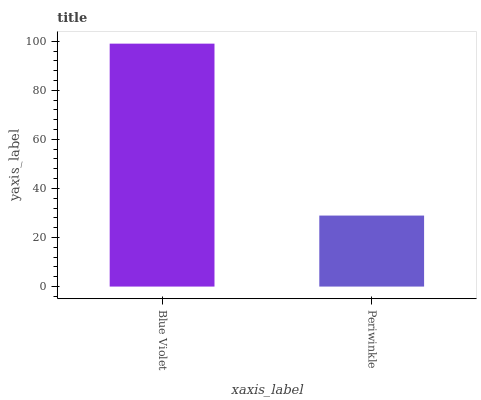Is Periwinkle the minimum?
Answer yes or no. Yes. Is Blue Violet the maximum?
Answer yes or no. Yes. Is Periwinkle the maximum?
Answer yes or no. No. Is Blue Violet greater than Periwinkle?
Answer yes or no. Yes. Is Periwinkle less than Blue Violet?
Answer yes or no. Yes. Is Periwinkle greater than Blue Violet?
Answer yes or no. No. Is Blue Violet less than Periwinkle?
Answer yes or no. No. Is Blue Violet the high median?
Answer yes or no. Yes. Is Periwinkle the low median?
Answer yes or no. Yes. Is Periwinkle the high median?
Answer yes or no. No. Is Blue Violet the low median?
Answer yes or no. No. 